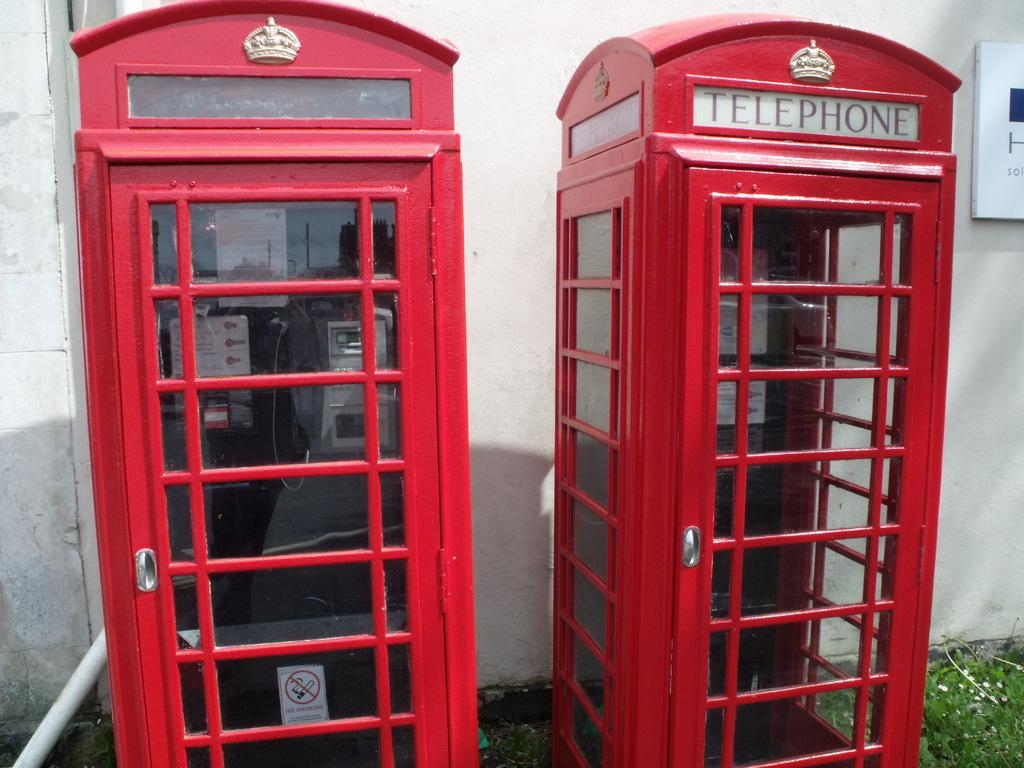<image>
Offer a succinct explanation of the picture presented. A red booth with the word Telephone on it. 